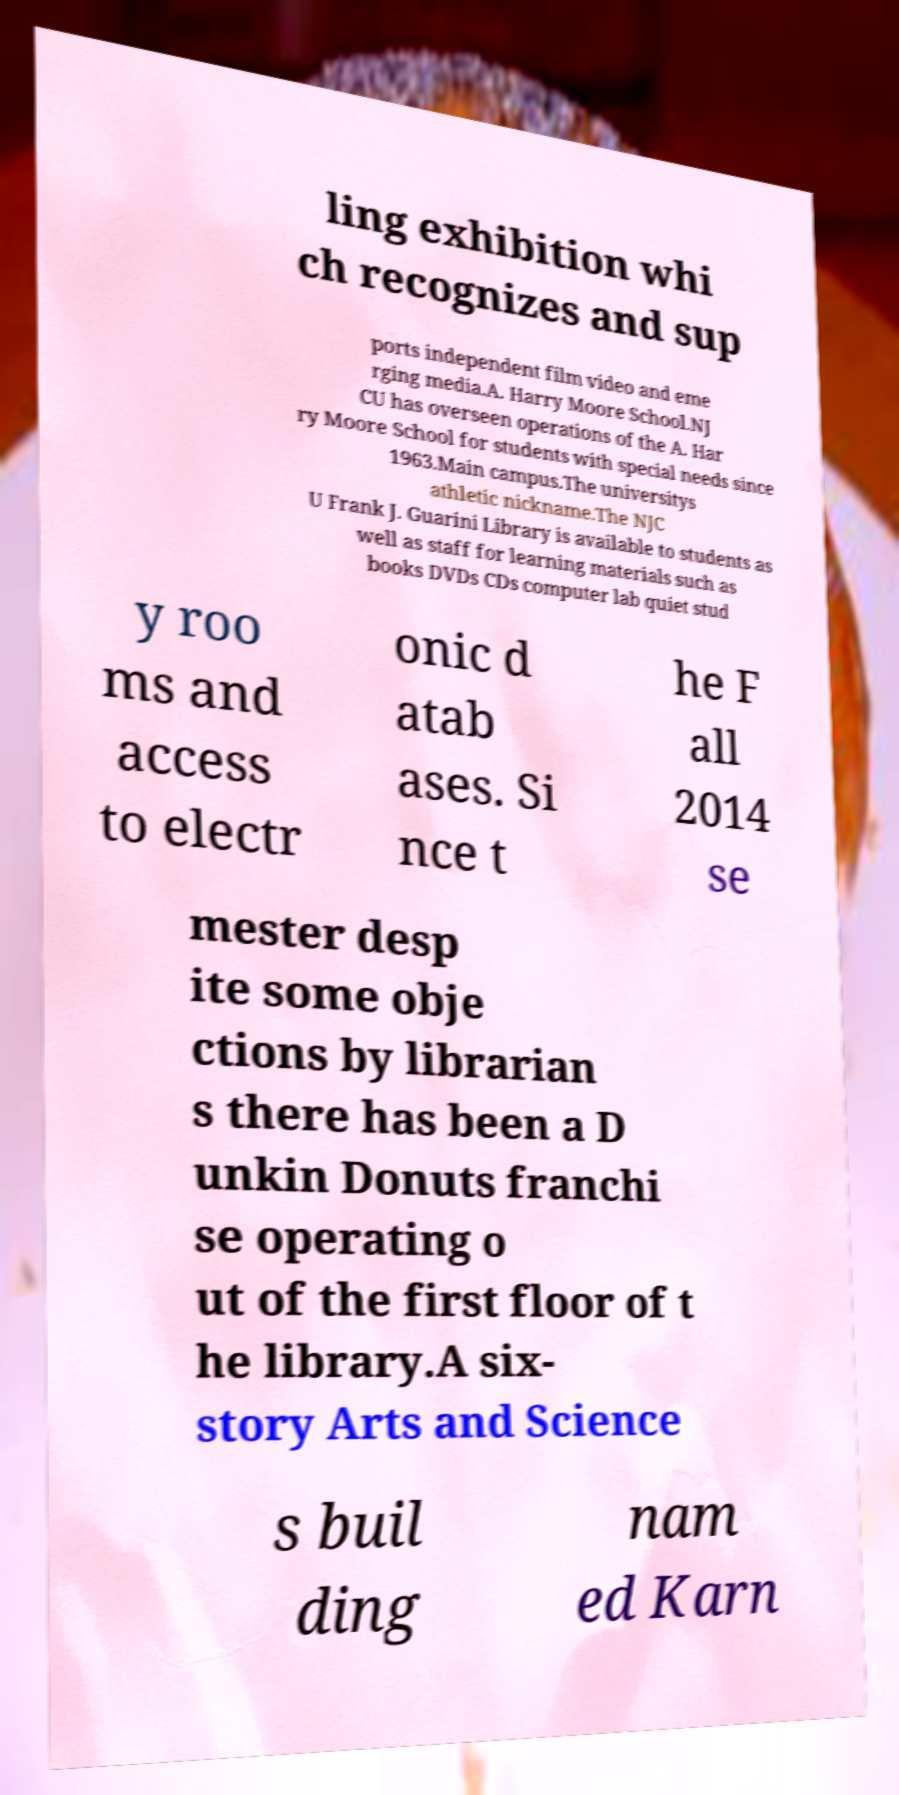I need the written content from this picture converted into text. Can you do that? ling exhibition whi ch recognizes and sup ports independent film video and eme rging media.A. Harry Moore School.NJ CU has overseen operations of the A. Har ry Moore School for students with special needs since 1963.Main campus.The universitys athletic nickname.The NJC U Frank J. Guarini Library is available to students as well as staff for learning materials such as books DVDs CDs computer lab quiet stud y roo ms and access to electr onic d atab ases. Si nce t he F all 2014 se mester desp ite some obje ctions by librarian s there has been a D unkin Donuts franchi se operating o ut of the first floor of t he library.A six- story Arts and Science s buil ding nam ed Karn 